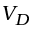<formula> <loc_0><loc_0><loc_500><loc_500>V _ { D }</formula> 